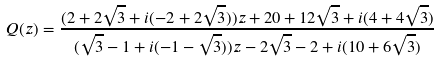<formula> <loc_0><loc_0><loc_500><loc_500>Q ( z ) = \frac { ( 2 + 2 \sqrt { 3 } + i ( - 2 + 2 \sqrt { 3 } ) ) z + 2 0 + 1 2 \sqrt { 3 } + i ( 4 + 4 \sqrt { 3 } ) } { ( \sqrt { 3 } - 1 + i ( - 1 - \sqrt { 3 } ) ) z - 2 \sqrt { 3 } - 2 + i ( 1 0 + 6 \sqrt { 3 } ) }</formula> 